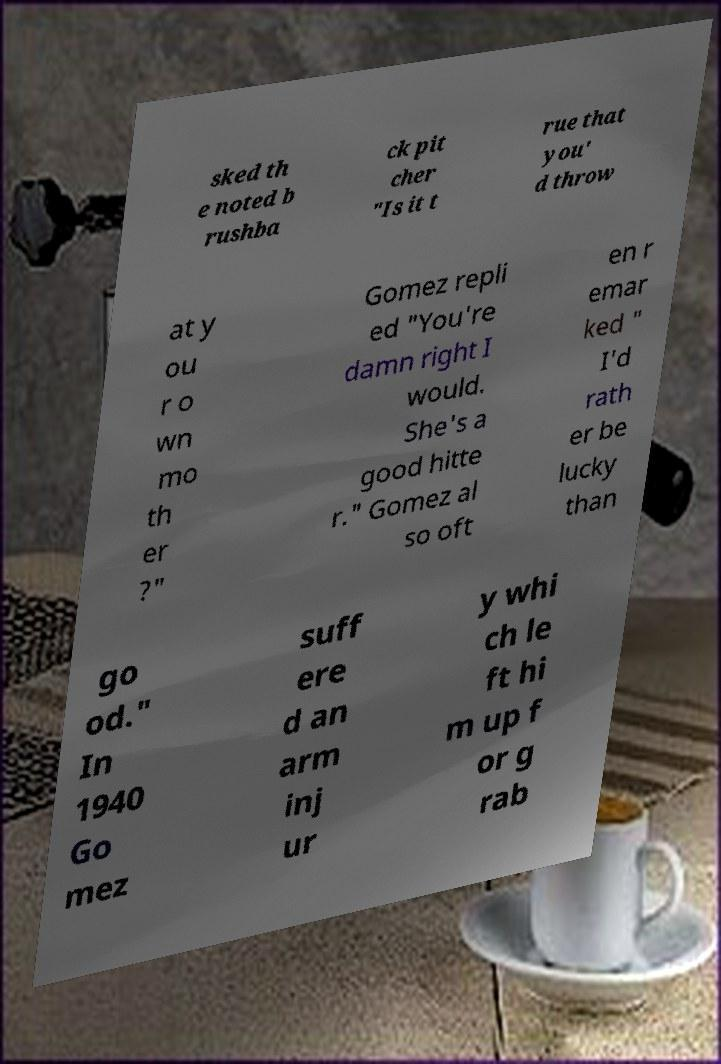Could you extract and type out the text from this image? sked th e noted b rushba ck pit cher "Is it t rue that you' d throw at y ou r o wn mo th er ?" Gomez repli ed "You're damn right I would. She's a good hitte r." Gomez al so oft en r emar ked " I'd rath er be lucky than go od." In 1940 Go mez suff ere d an arm inj ur y whi ch le ft hi m up f or g rab 